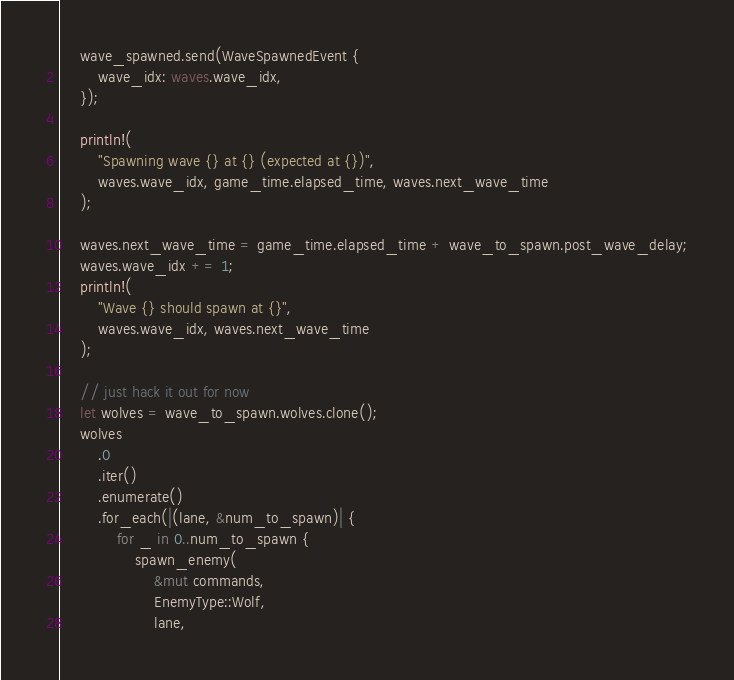<code> <loc_0><loc_0><loc_500><loc_500><_Rust_>    wave_spawned.send(WaveSpawnedEvent {
        wave_idx: waves.wave_idx,
    });

    println!(
        "Spawning wave {} at {} (expected at {})",
        waves.wave_idx, game_time.elapsed_time, waves.next_wave_time
    );

    waves.next_wave_time = game_time.elapsed_time + wave_to_spawn.post_wave_delay;
    waves.wave_idx += 1;
    println!(
        "Wave {} should spawn at {}",
        waves.wave_idx, waves.next_wave_time
    );

    // just hack it out for now
    let wolves = wave_to_spawn.wolves.clone();
    wolves
        .0
        .iter()
        .enumerate()
        .for_each(|(lane, &num_to_spawn)| {
            for _ in 0..num_to_spawn {
                spawn_enemy(
                    &mut commands,
                    EnemyType::Wolf,
                    lane,</code> 